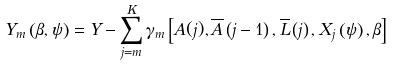Convert formula to latex. <formula><loc_0><loc_0><loc_500><loc_500>\ Y _ { m } \left ( \beta , \psi \right ) = Y - \sum _ { j = m } ^ { K } \gamma _ { m } \left [ A ( j ) , \overline { A } \left ( j - 1 \right ) , \overline { L } \left ( j \right ) , X _ { j } \left ( \psi \right ) , \beta \right ]</formula> 